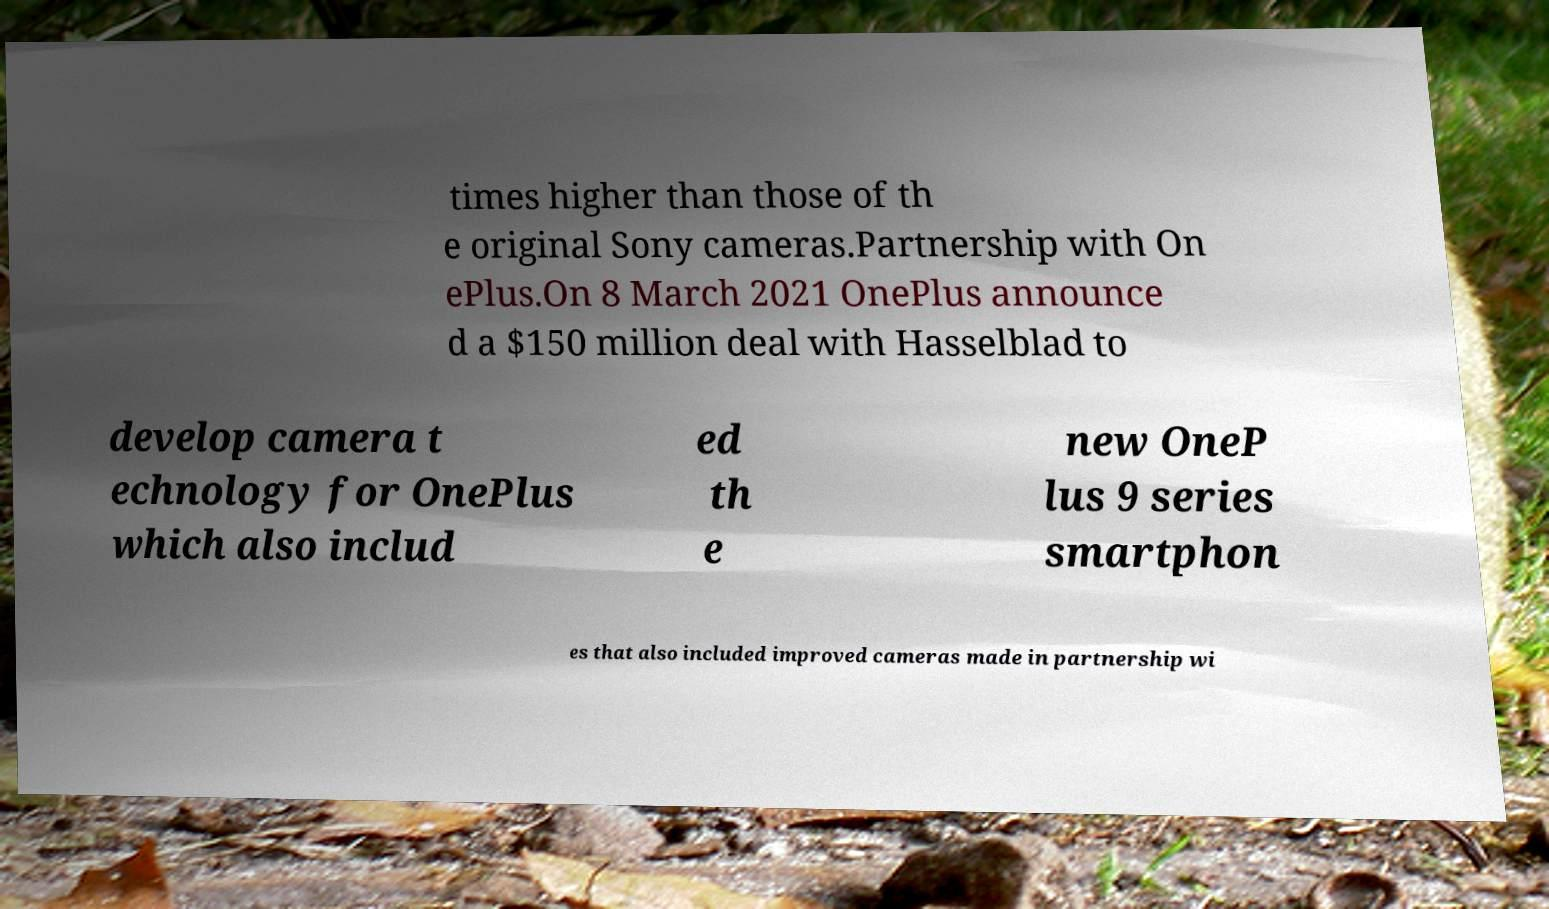Please identify and transcribe the text found in this image. times higher than those of th e original Sony cameras.Partnership with On ePlus.On 8 March 2021 OnePlus announce d a $150 million deal with Hasselblad to develop camera t echnology for OnePlus which also includ ed th e new OneP lus 9 series smartphon es that also included improved cameras made in partnership wi 